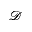Convert formula to latex. <formula><loc_0><loc_0><loc_500><loc_500>\mathcal { D }</formula> 